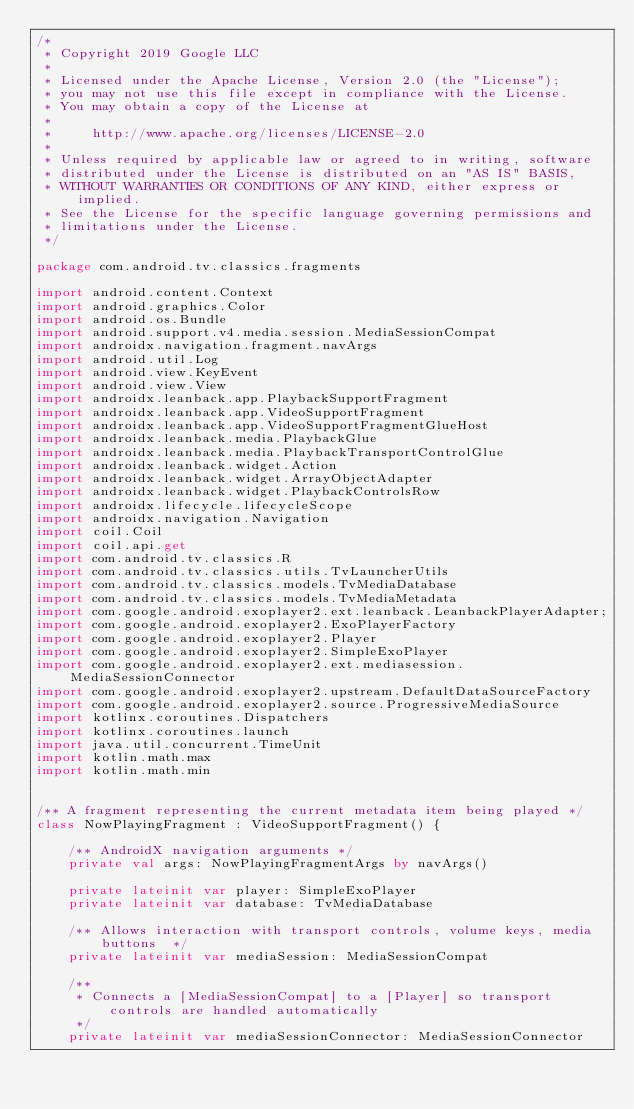Convert code to text. <code><loc_0><loc_0><loc_500><loc_500><_Kotlin_>/*
 * Copyright 2019 Google LLC
 *
 * Licensed under the Apache License, Version 2.0 (the "License");
 * you may not use this file except in compliance with the License.
 * You may obtain a copy of the License at
 *
 *     http://www.apache.org/licenses/LICENSE-2.0
 *
 * Unless required by applicable law or agreed to in writing, software
 * distributed under the License is distributed on an "AS IS" BASIS,
 * WITHOUT WARRANTIES OR CONDITIONS OF ANY KIND, either express or implied.
 * See the License for the specific language governing permissions and
 * limitations under the License.
 */

package com.android.tv.classics.fragments

import android.content.Context
import android.graphics.Color
import android.os.Bundle
import android.support.v4.media.session.MediaSessionCompat
import androidx.navigation.fragment.navArgs
import android.util.Log
import android.view.KeyEvent
import android.view.View
import androidx.leanback.app.PlaybackSupportFragment
import androidx.leanback.app.VideoSupportFragment
import androidx.leanback.app.VideoSupportFragmentGlueHost
import androidx.leanback.media.PlaybackGlue
import androidx.leanback.media.PlaybackTransportControlGlue
import androidx.leanback.widget.Action
import androidx.leanback.widget.ArrayObjectAdapter
import androidx.leanback.widget.PlaybackControlsRow
import androidx.lifecycle.lifecycleScope
import androidx.navigation.Navigation
import coil.Coil
import coil.api.get
import com.android.tv.classics.R
import com.android.tv.classics.utils.TvLauncherUtils
import com.android.tv.classics.models.TvMediaDatabase
import com.android.tv.classics.models.TvMediaMetadata
import com.google.android.exoplayer2.ext.leanback.LeanbackPlayerAdapter;
import com.google.android.exoplayer2.ExoPlayerFactory
import com.google.android.exoplayer2.Player
import com.google.android.exoplayer2.SimpleExoPlayer
import com.google.android.exoplayer2.ext.mediasession.MediaSessionConnector
import com.google.android.exoplayer2.upstream.DefaultDataSourceFactory
import com.google.android.exoplayer2.source.ProgressiveMediaSource
import kotlinx.coroutines.Dispatchers
import kotlinx.coroutines.launch
import java.util.concurrent.TimeUnit
import kotlin.math.max
import kotlin.math.min


/** A fragment representing the current metadata item being played */
class NowPlayingFragment : VideoSupportFragment() {

    /** AndroidX navigation arguments */
    private val args: NowPlayingFragmentArgs by navArgs()

    private lateinit var player: SimpleExoPlayer
    private lateinit var database: TvMediaDatabase

    /** Allows interaction with transport controls, volume keys, media buttons  */
    private lateinit var mediaSession: MediaSessionCompat

    /**
     * Connects a [MediaSessionCompat] to a [Player] so transport controls are handled automatically
     */
    private lateinit var mediaSessionConnector: MediaSessionConnector
</code> 